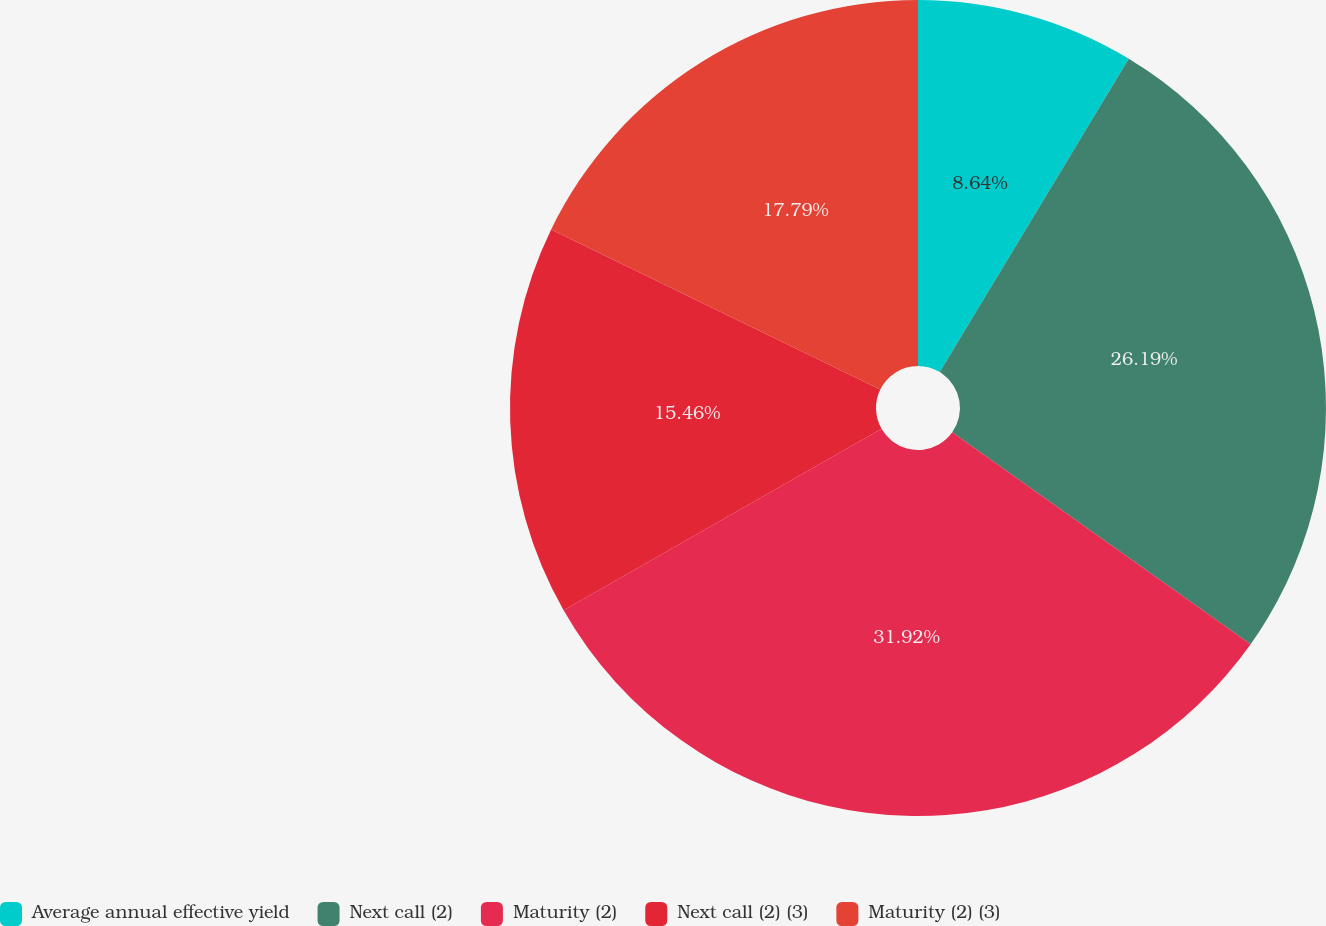Convert chart. <chart><loc_0><loc_0><loc_500><loc_500><pie_chart><fcel>Average annual effective yield<fcel>Next call (2)<fcel>Maturity (2)<fcel>Next call (2) (3)<fcel>Maturity (2) (3)<nl><fcel>8.64%<fcel>26.19%<fcel>31.92%<fcel>15.46%<fcel>17.79%<nl></chart> 